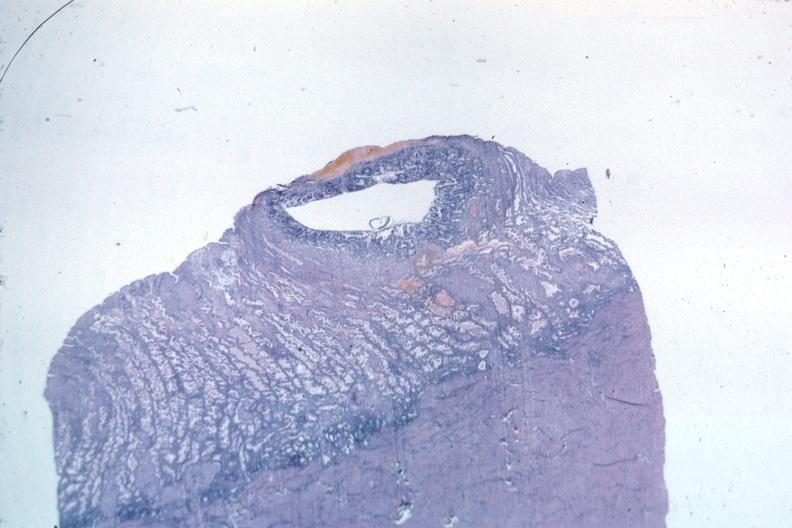s coronary atherosclerosis present?
Answer the question using a single word or phrase. No 